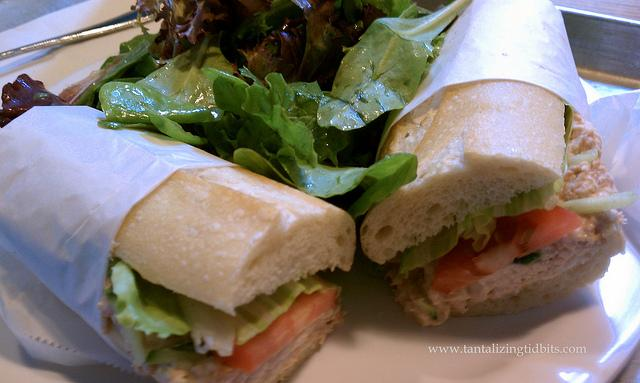What animal will most likely eat this meal? Please explain your reasoning. human. Only humans will make this and eat it. 